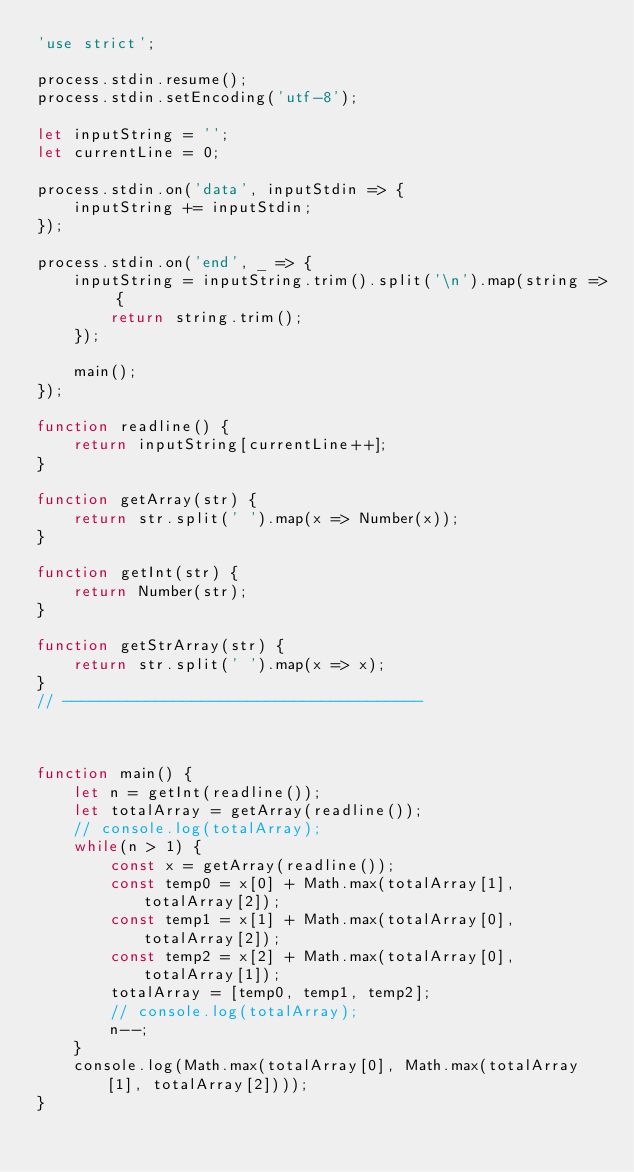Convert code to text. <code><loc_0><loc_0><loc_500><loc_500><_JavaScript_>'use strict';

process.stdin.resume();
process.stdin.setEncoding('utf-8');

let inputString = '';
let currentLine = 0;

process.stdin.on('data', inputStdin => {
    inputString += inputStdin;
});

process.stdin.on('end', _ => {
    inputString = inputString.trim().split('\n').map(string => {
        return string.trim();
    });

    main();
});

function readline() {
    return inputString[currentLine++];
}

function getArray(str) {
    return str.split(' ').map(x => Number(x));
}

function getInt(str) {
    return Number(str);
}

function getStrArray(str) {
    return str.split(' ').map(x => x);
}
// ---------------------------------------



function main() {
    let n = getInt(readline());
    let totalArray = getArray(readline());
    // console.log(totalArray);
    while(n > 1) {
        const x = getArray(readline());
        const temp0 = x[0] + Math.max(totalArray[1], totalArray[2]);
        const temp1 = x[1] + Math.max(totalArray[0], totalArray[2]);
        const temp2 = x[2] + Math.max(totalArray[0], totalArray[1]);
        totalArray = [temp0, temp1, temp2];
        // console.log(totalArray);
        n--;
    }
    console.log(Math.max(totalArray[0], Math.max(totalArray[1], totalArray[2])));
}</code> 